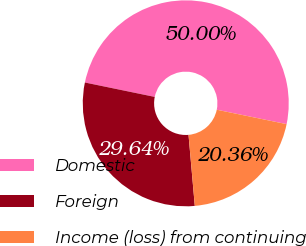Convert chart. <chart><loc_0><loc_0><loc_500><loc_500><pie_chart><fcel>Domestic<fcel>Foreign<fcel>Income (loss) from continuing<nl><fcel>50.0%<fcel>29.64%<fcel>20.36%<nl></chart> 